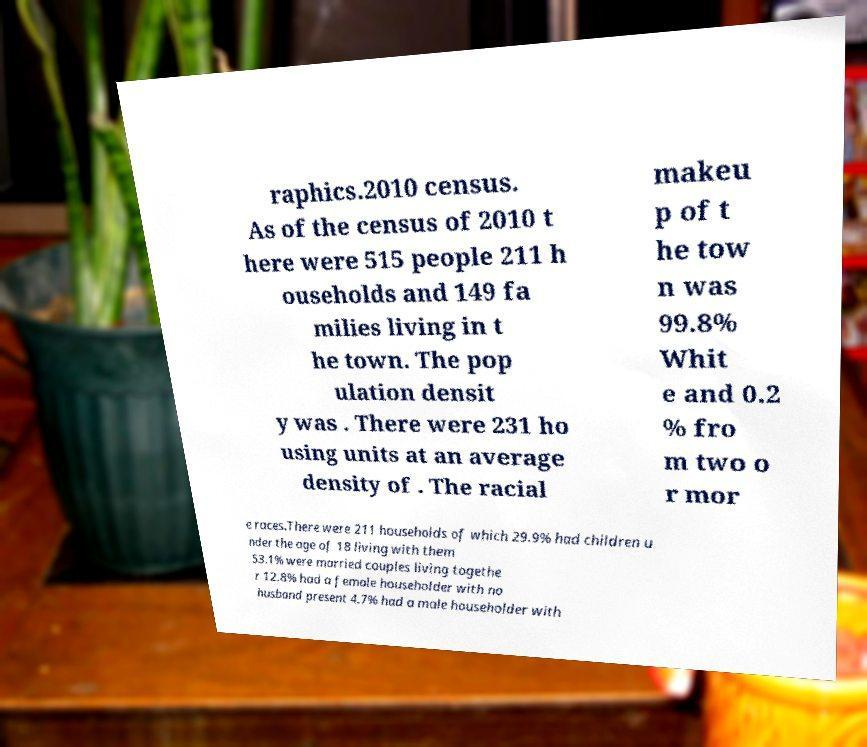Could you extract and type out the text from this image? raphics.2010 census. As of the census of 2010 t here were 515 people 211 h ouseholds and 149 fa milies living in t he town. The pop ulation densit y was . There were 231 ho using units at an average density of . The racial makeu p of t he tow n was 99.8% Whit e and 0.2 % fro m two o r mor e races.There were 211 households of which 29.9% had children u nder the age of 18 living with them 53.1% were married couples living togethe r 12.8% had a female householder with no husband present 4.7% had a male householder with 